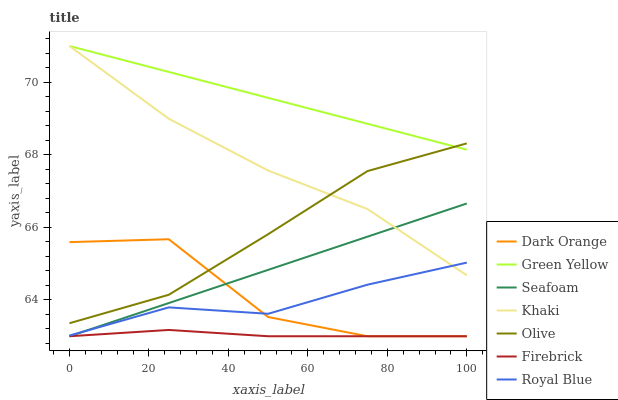Does Firebrick have the minimum area under the curve?
Answer yes or no. Yes. Does Green Yellow have the maximum area under the curve?
Answer yes or no. Yes. Does Khaki have the minimum area under the curve?
Answer yes or no. No. Does Khaki have the maximum area under the curve?
Answer yes or no. No. Is Seafoam the smoothest?
Answer yes or no. Yes. Is Dark Orange the roughest?
Answer yes or no. Yes. Is Khaki the smoothest?
Answer yes or no. No. Is Khaki the roughest?
Answer yes or no. No. Does Dark Orange have the lowest value?
Answer yes or no. Yes. Does Khaki have the lowest value?
Answer yes or no. No. Does Green Yellow have the highest value?
Answer yes or no. Yes. Does Firebrick have the highest value?
Answer yes or no. No. Is Royal Blue less than Olive?
Answer yes or no. Yes. Is Green Yellow greater than Seafoam?
Answer yes or no. Yes. Does Royal Blue intersect Khaki?
Answer yes or no. Yes. Is Royal Blue less than Khaki?
Answer yes or no. No. Is Royal Blue greater than Khaki?
Answer yes or no. No. Does Royal Blue intersect Olive?
Answer yes or no. No. 